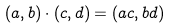Convert formula to latex. <formula><loc_0><loc_0><loc_500><loc_500>( a , b ) \cdot ( c , d ) = ( a c , b d )</formula> 